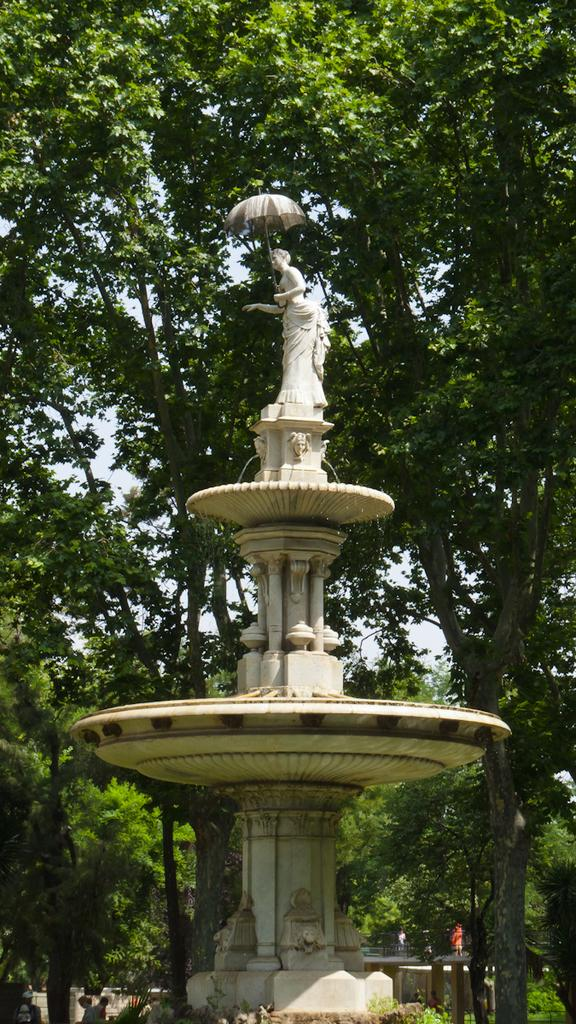What is the main subject in the image? There is a statue in the image. What type of vegetation can be seen in the image? There are green trees in the image. What is visible in the background of the image? The sky is visible in the image. What type of pollution can be seen in the image? There is no pollution visible in the image. What type of sand can be seen in the image? There is no sand present in the image. 